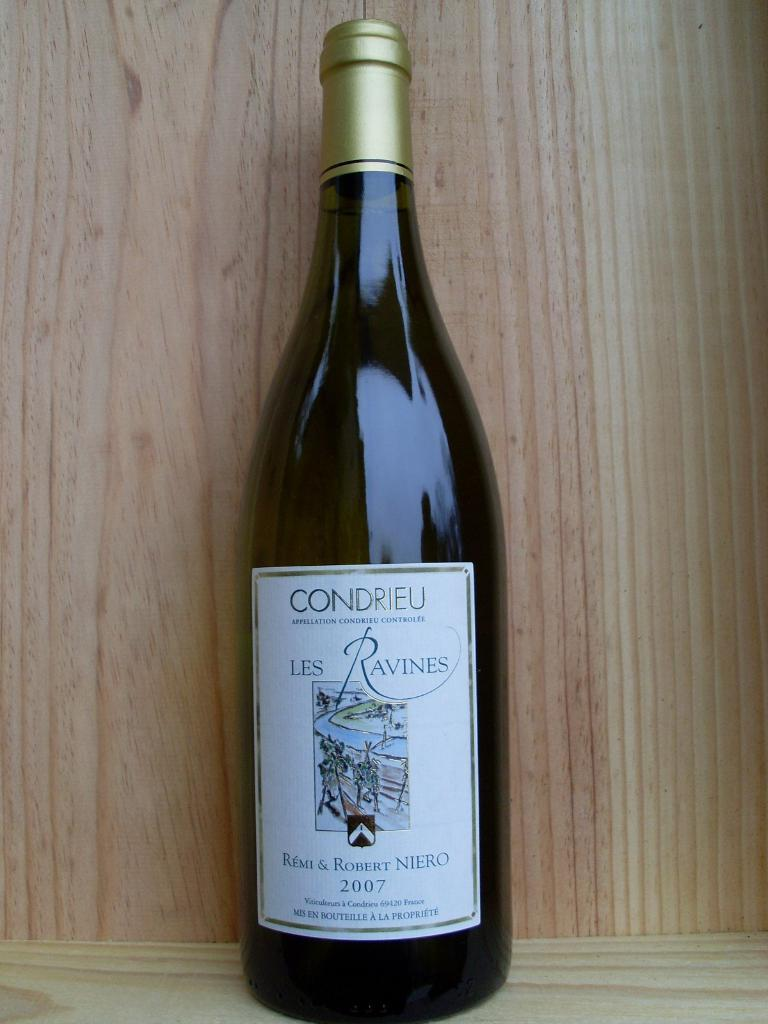<image>
Create a compact narrative representing the image presented. An unopened bottle of Les Ravines dated 2007. 